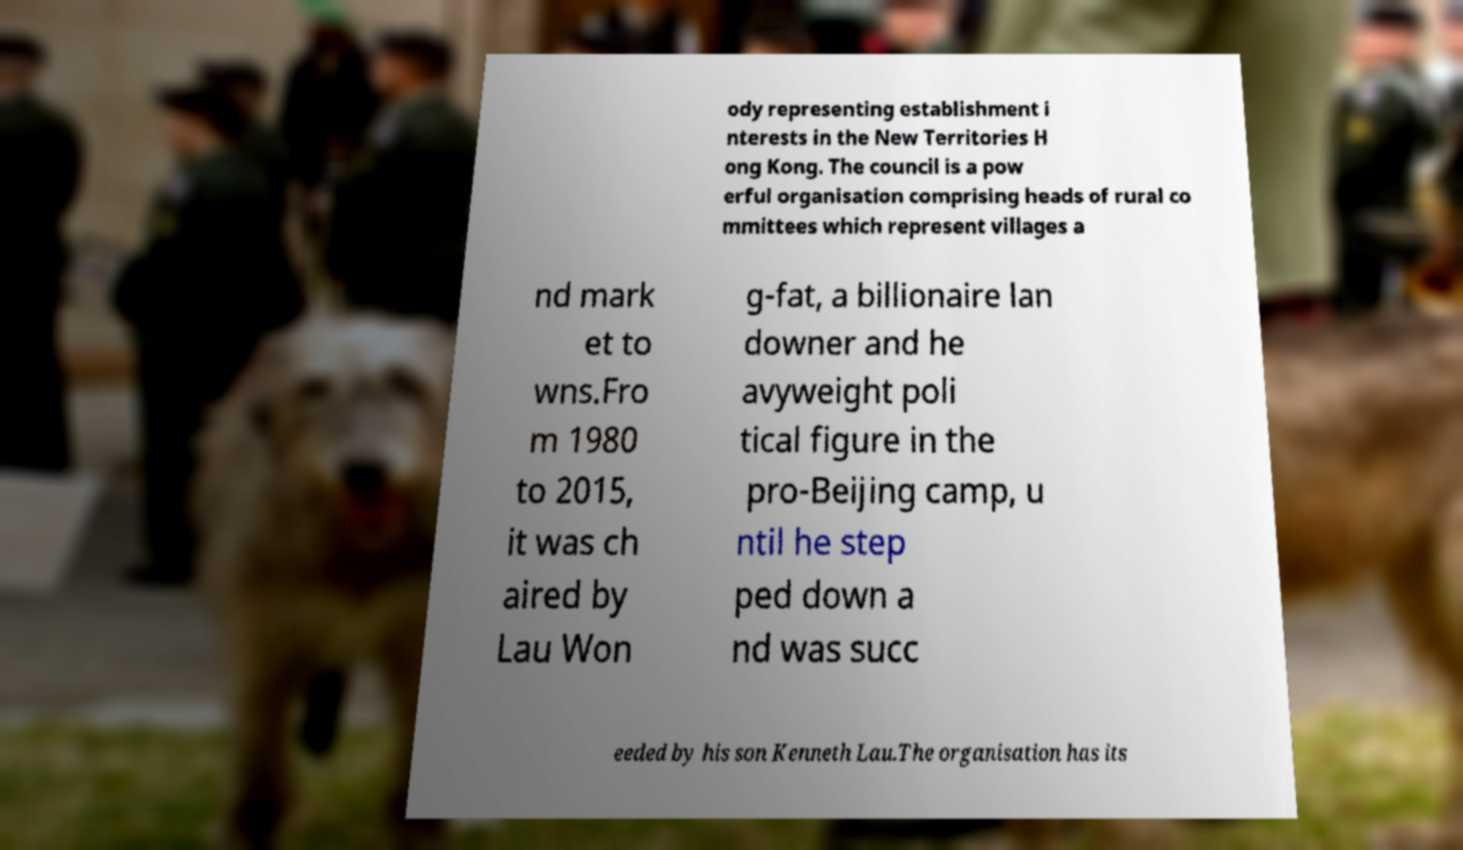For documentation purposes, I need the text within this image transcribed. Could you provide that? ody representing establishment i nterests in the New Territories H ong Kong. The council is a pow erful organisation comprising heads of rural co mmittees which represent villages a nd mark et to wns.Fro m 1980 to 2015, it was ch aired by Lau Won g-fat, a billionaire lan downer and he avyweight poli tical figure in the pro-Beijing camp, u ntil he step ped down a nd was succ eeded by his son Kenneth Lau.The organisation has its 